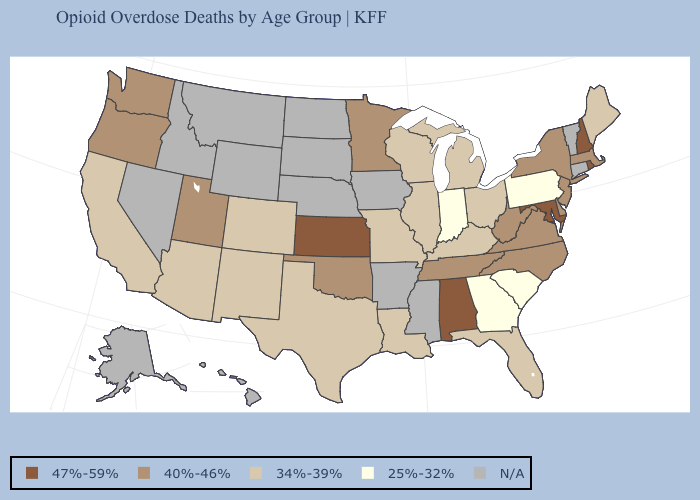Which states have the highest value in the USA?
Give a very brief answer. Alabama, Kansas, Maryland, New Hampshire, Rhode Island. Name the states that have a value in the range 34%-39%?
Be succinct. Arizona, California, Colorado, Florida, Illinois, Kentucky, Louisiana, Maine, Michigan, Missouri, New Mexico, Ohio, Texas, Wisconsin. Among the states that border Maine , which have the highest value?
Answer briefly. New Hampshire. Name the states that have a value in the range N/A?
Quick response, please. Alaska, Arkansas, Connecticut, Hawaii, Idaho, Iowa, Mississippi, Montana, Nebraska, Nevada, North Dakota, South Dakota, Vermont, Wyoming. Does Maryland have the highest value in the South?
Write a very short answer. Yes. Does Washington have the highest value in the West?
Keep it brief. Yes. Which states have the lowest value in the USA?
Keep it brief. Georgia, Indiana, Pennsylvania, South Carolina. What is the value of Louisiana?
Keep it brief. 34%-39%. What is the value of New Hampshire?
Concise answer only. 47%-59%. Does Texas have the highest value in the USA?
Write a very short answer. No. What is the value of Arkansas?
Concise answer only. N/A. Among the states that border Mississippi , does Alabama have the highest value?
Keep it brief. Yes. Name the states that have a value in the range 25%-32%?
Keep it brief. Georgia, Indiana, Pennsylvania, South Carolina. What is the lowest value in the USA?
Concise answer only. 25%-32%. Does Arizona have the highest value in the West?
Answer briefly. No. 